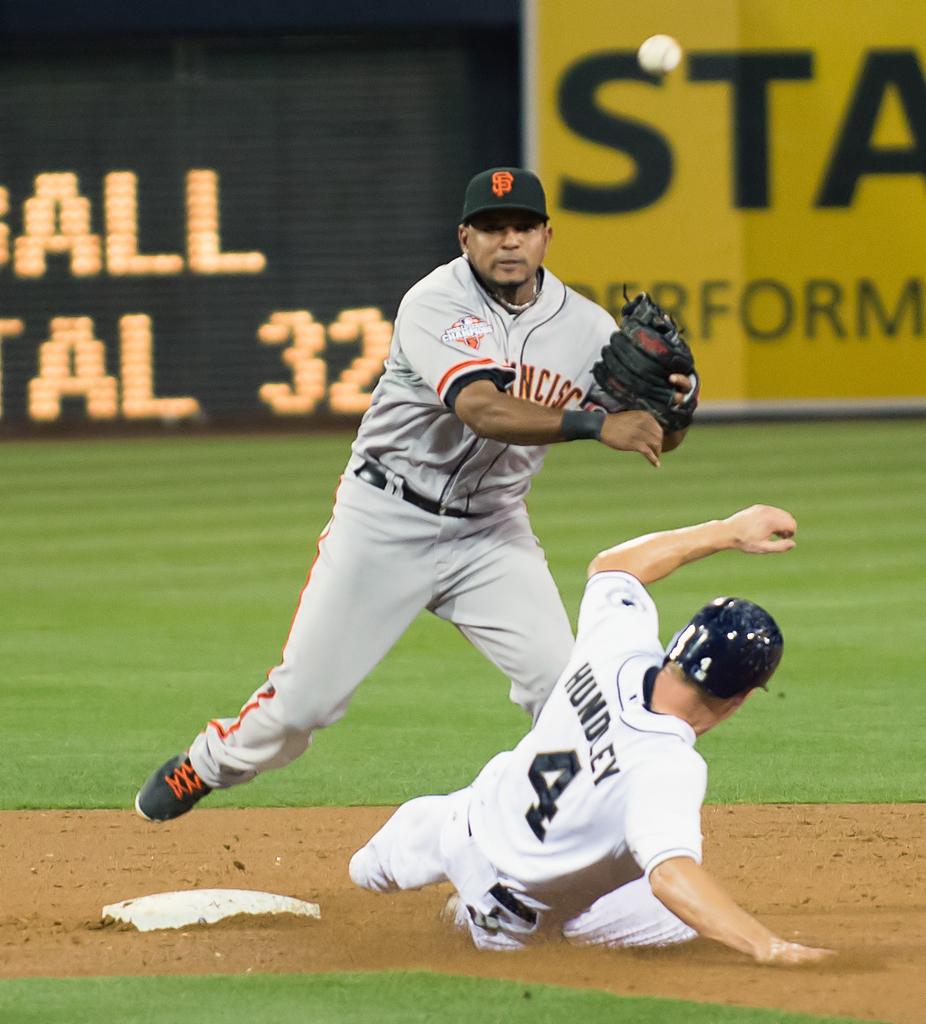Who is sliding into the base?
Ensure brevity in your answer.  Hundley. What number is the person who is sliding?
Ensure brevity in your answer.  4. 